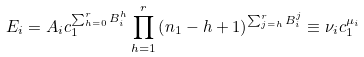Convert formula to latex. <formula><loc_0><loc_0><loc_500><loc_500>E _ { i } = A _ { i } c _ { 1 } ^ { \sum _ { h = 0 } ^ { r } B _ { i } ^ { h } } \prod _ { h = 1 } ^ { r } \left ( n _ { 1 } - h + 1 \right ) ^ { \sum _ { j = h } ^ { r } B _ { i } ^ { j } } \equiv \nu _ { i } c _ { 1 } ^ { \mu _ { i } }</formula> 